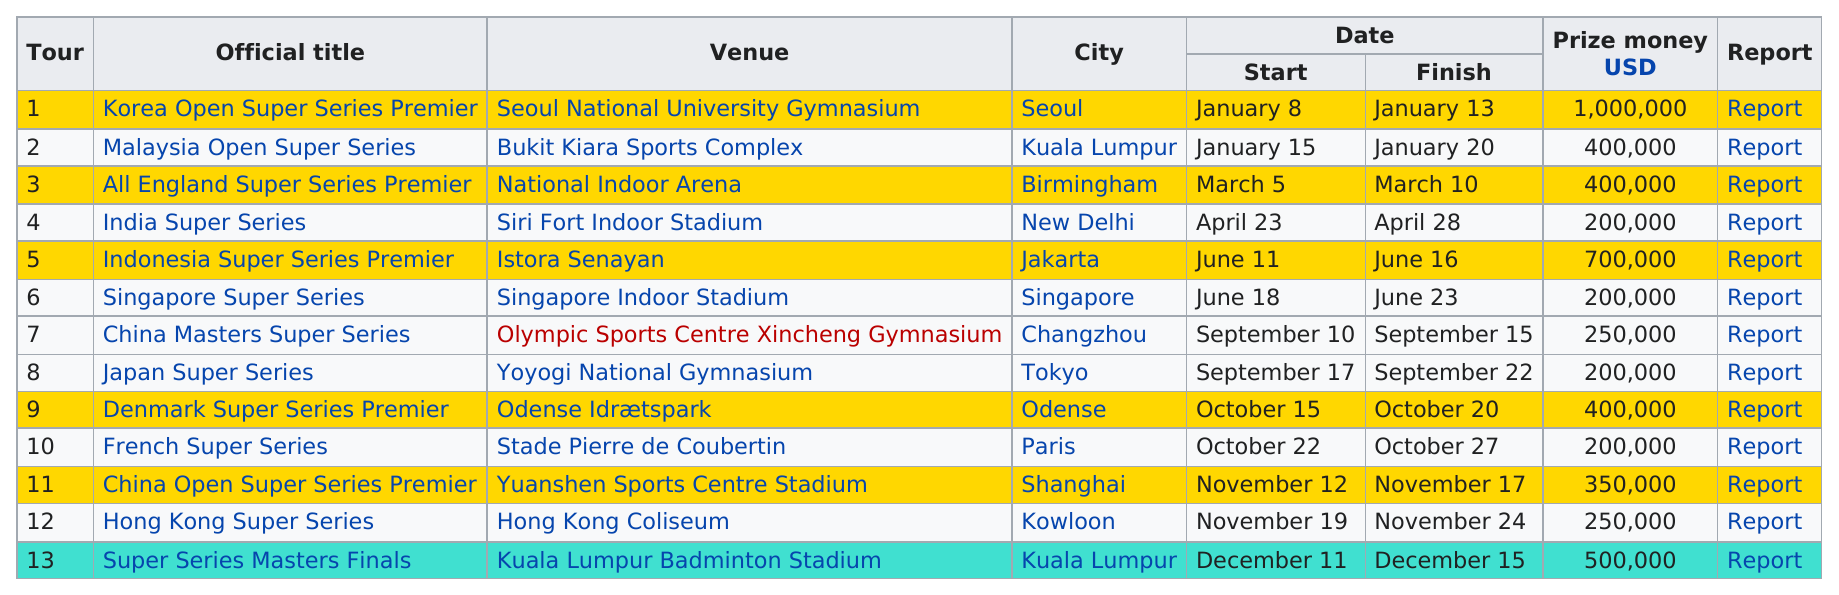Indicate a few pertinent items in this graphic. The Malaysia Open Super Series pays less than the French Super Series. The total prize payout for all 13 series is 5050000. The Japan Super Series lasted for a total of five days. Three series have awarded at least $500,000 in prize money. The Korea Open Super Series Premier is a series of badminton tournaments with the highest prize payout among all the series. 